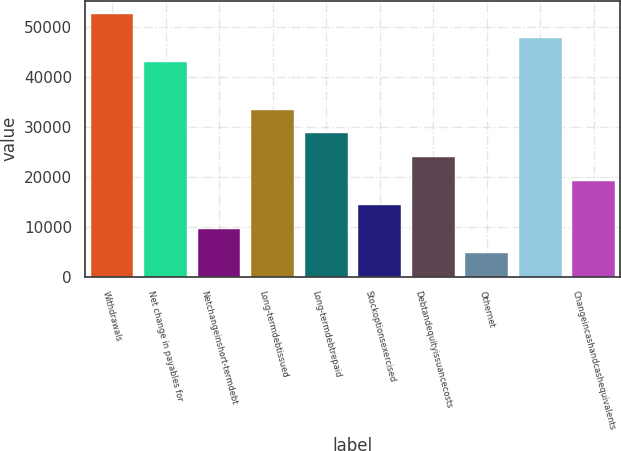<chart> <loc_0><loc_0><loc_500><loc_500><bar_chart><fcel>Withdrawals<fcel>Net change in payables for<fcel>Netchangeinshort-termdebt<fcel>Long-termdebtissued<fcel>Long-termdebtrepaid<fcel>Stockoptionsexercised<fcel>Debtandequityissuancecosts<fcel>Othernet<fcel>Unnamed: 8<fcel>Changeincashandcashequivalents<nl><fcel>52609.6<fcel>43044.4<fcel>9566.2<fcel>33479.2<fcel>28696.6<fcel>14348.8<fcel>23914<fcel>4783.6<fcel>47827<fcel>19131.4<nl></chart> 